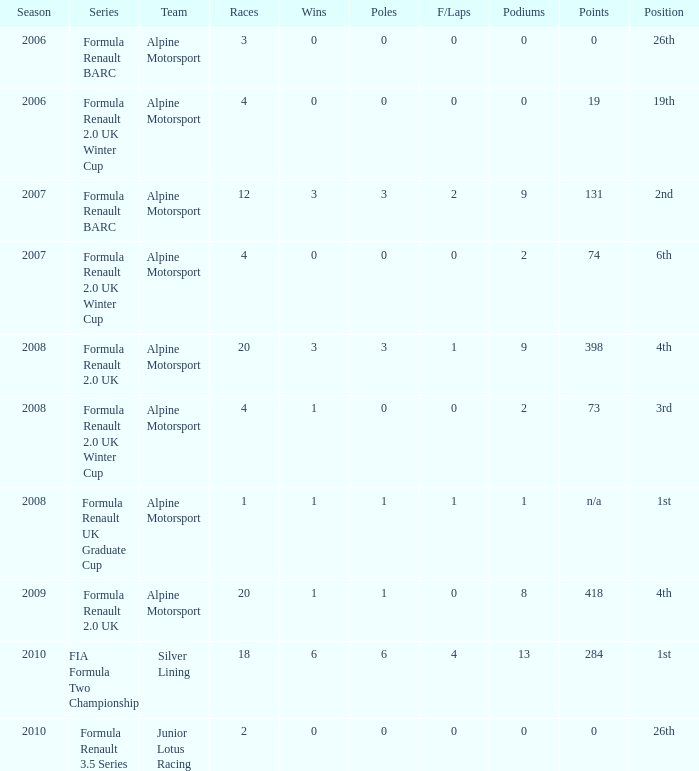When was the initial season that featured a podium consisting of 9? 2007.0. 